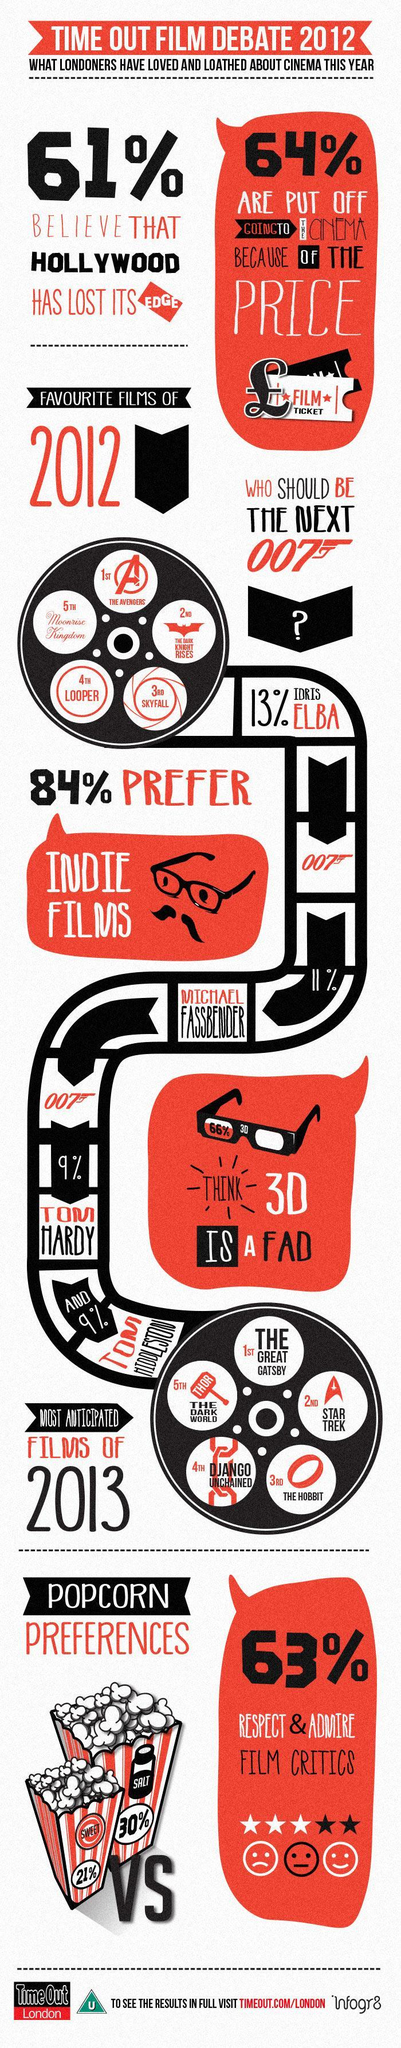What is the biggest reason that people are not interested in going to cinema?
Answer the question with a short phrase. PRICE What percentage of people do not respect and admire film critics? 37% Which is the third favourite movie of 2012? SKYFALL What percent of people like Indie films? 84% What percentage of people do not think that 3D is a fad? 34% What percentage of people wantTom Hardy to play next Bond? 9% Which is the third most anticipated film of 2013? THE HOBBIT Whom does 11 % of people want to play Bond? MICHAEL FASSBENDER Which popcorn does most people prefer among the two shown? SALT 